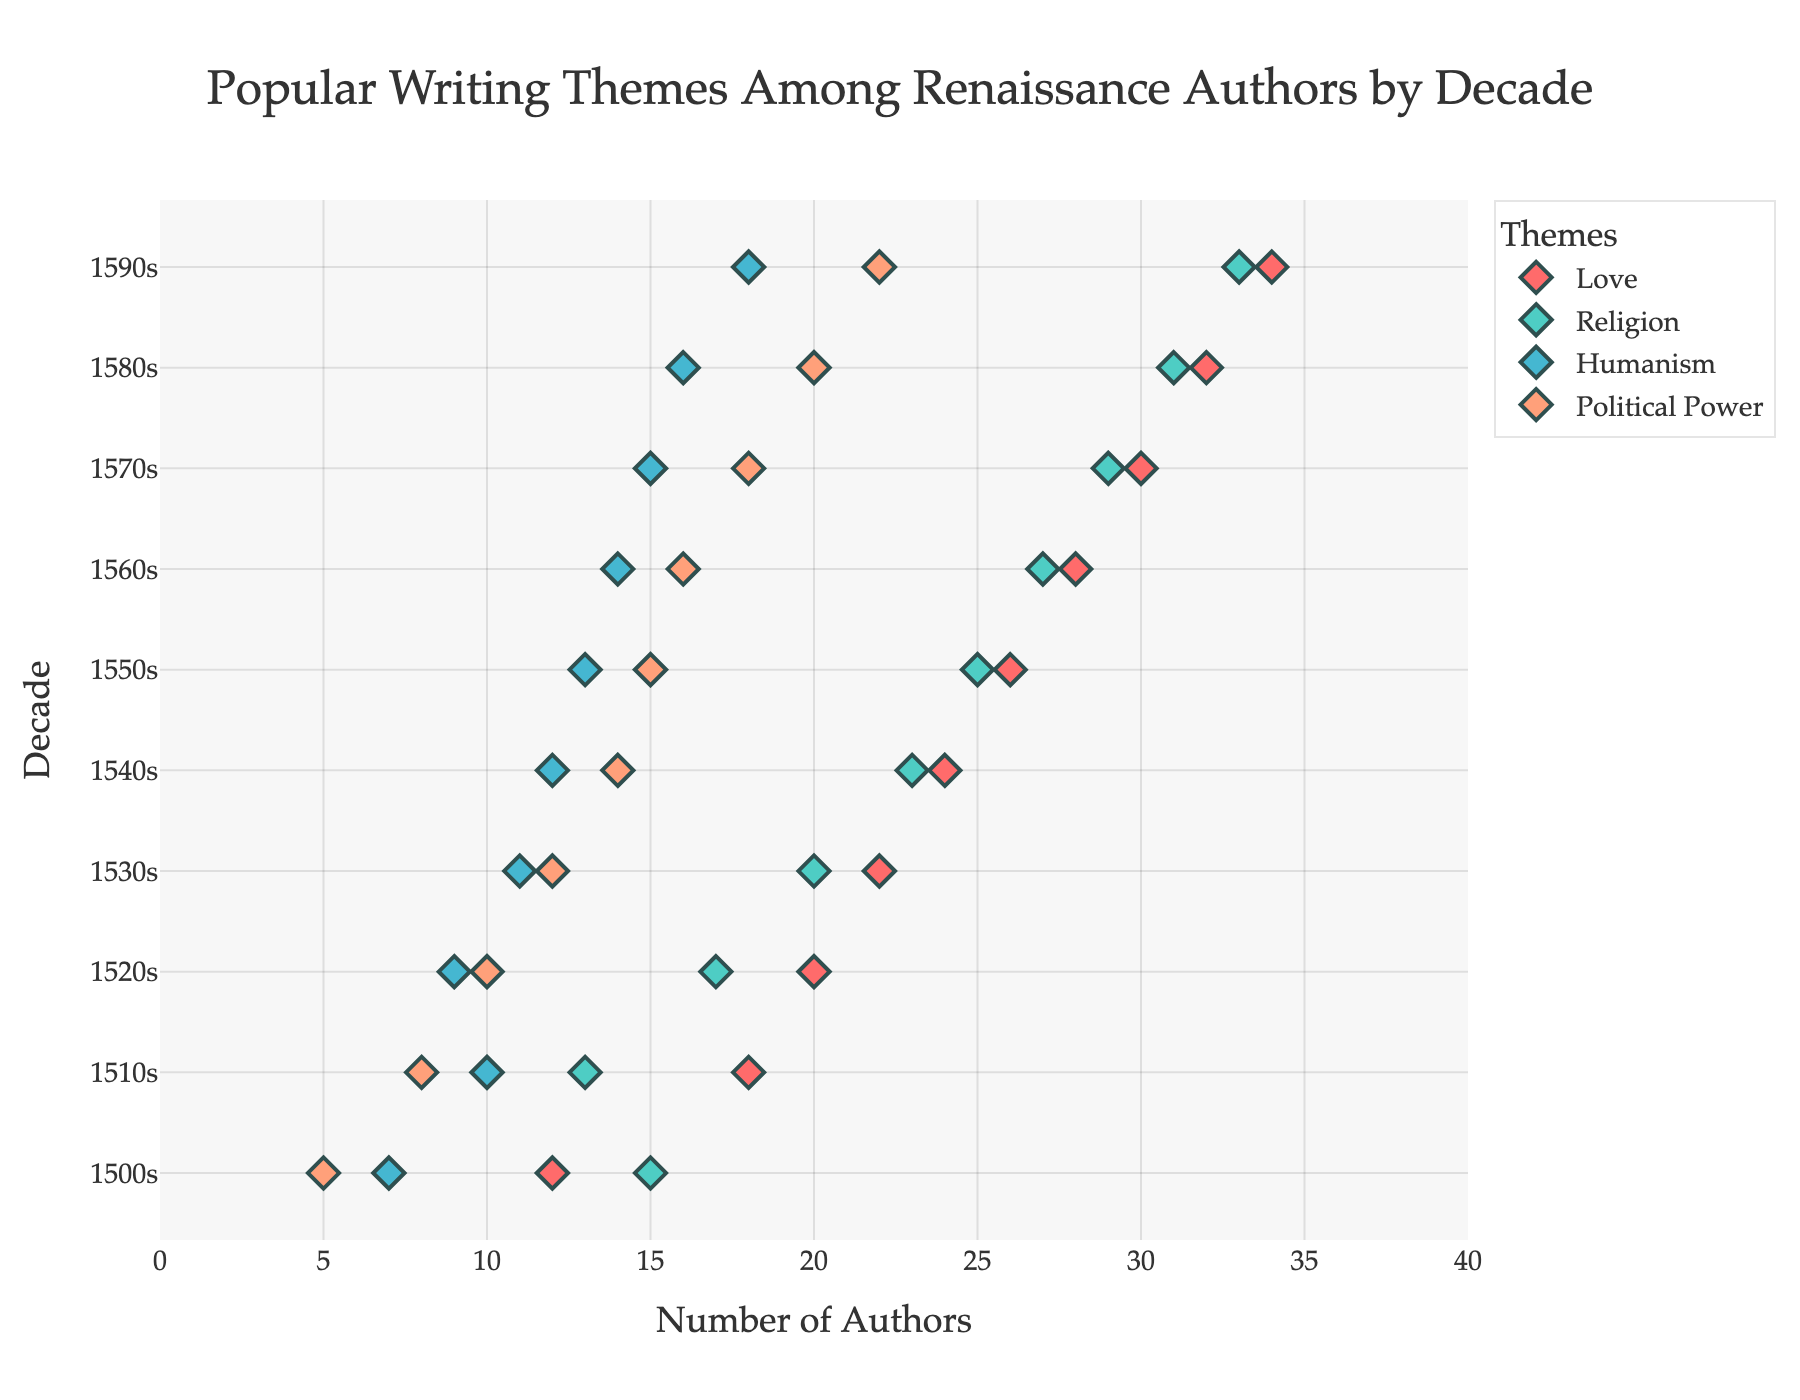What is the most popular theme among Renaissance authors in the 1500s? We look at the data points for the 1500s and compare the counts for each theme. Love has 12 authors, Religion has 15 authors, Humanism has 7 authors, and Political Power has 5 authors. Therefore, Religion is the most popular theme.
Answer: Religion Which decade saw the highest interest in the theme of Love? By checking the counts of the Love theme across all decades, we see the counts rise steadily to their highest in the 1590s with 34 authors.
Answer: 1590s How did the interest in Humanism change from the 1500s to the 1510s? We compare the authors count for Humanism in the 1500s (7) to the count in the 1510s (10). The interest in Humanism increased by 3 authors.
Answer: Increased by 3 In which decade did Political Power first reach 20 authors? Scanning the counts for Political Power, we find that the number first reached 20 authors in the 1580s.
Answer: 1580s Which theme had the smallest increase in author interest from the 1530s to the 1540s? We compare the increases for each theme: Love goes from 22 to 24 (an increase of 2), Religion goes from 20 to 23 (an increase of 3), Humanism goes from 11 to 12 (an increase of 1), and Political Power goes from 12 to 14 (an increase of 2). Humanism had the smallest increase.
Answer: Humanism How many total authors focused on Religion across all decades? Summing the counts for Religion across all decades: 15 + 13 + 17 + 20 + 23 + 25 + 27 + 29 + 31 + 33 = 233 authors.
Answer: 233 Which theme shows the most consistent increase in interest over the decades? By checking each theme's author's count over the decades, Love increases steadily from 12 to 34, whereas other themes have varying increments. Love shows the most consistent increase.
Answer: Love What is the range of interest in the Humanism theme across all decades? Identifying the minimum and maximum counts for Humanism: minimum is 7 (1500s) and maximum is 18 (1590s). Therefore, the range is 18 - 7 = 11.
Answer: 11 